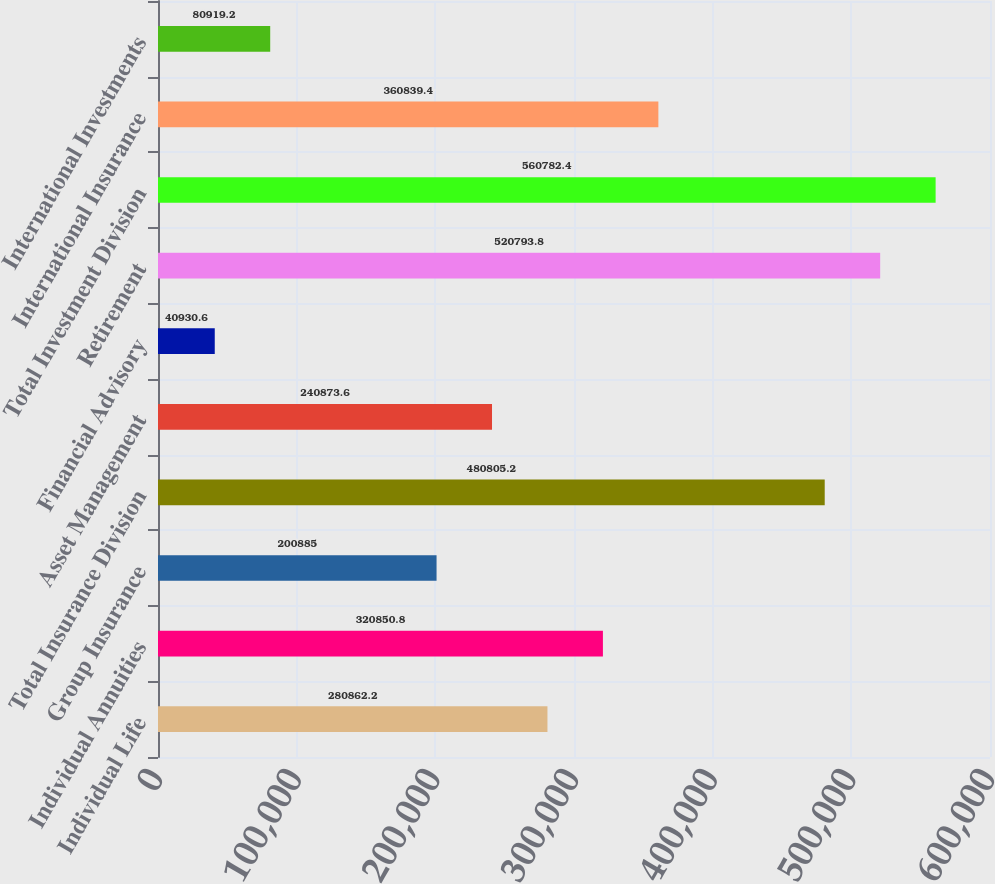<chart> <loc_0><loc_0><loc_500><loc_500><bar_chart><fcel>Individual Life<fcel>Individual Annuities<fcel>Group Insurance<fcel>Total Insurance Division<fcel>Asset Management<fcel>Financial Advisory<fcel>Retirement<fcel>Total Investment Division<fcel>International Insurance<fcel>International Investments<nl><fcel>280862<fcel>320851<fcel>200885<fcel>480805<fcel>240874<fcel>40930.6<fcel>520794<fcel>560782<fcel>360839<fcel>80919.2<nl></chart> 